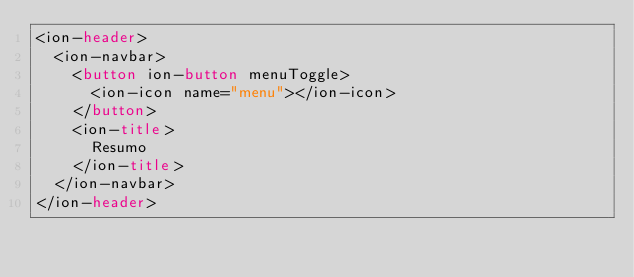Convert code to text. <code><loc_0><loc_0><loc_500><loc_500><_HTML_><ion-header>
  <ion-navbar>
    <button ion-button menuToggle>
      <ion-icon name="menu"></ion-icon>
    </button>
    <ion-title>
      Resumo
    </ion-title>
  </ion-navbar>
</ion-header></code> 